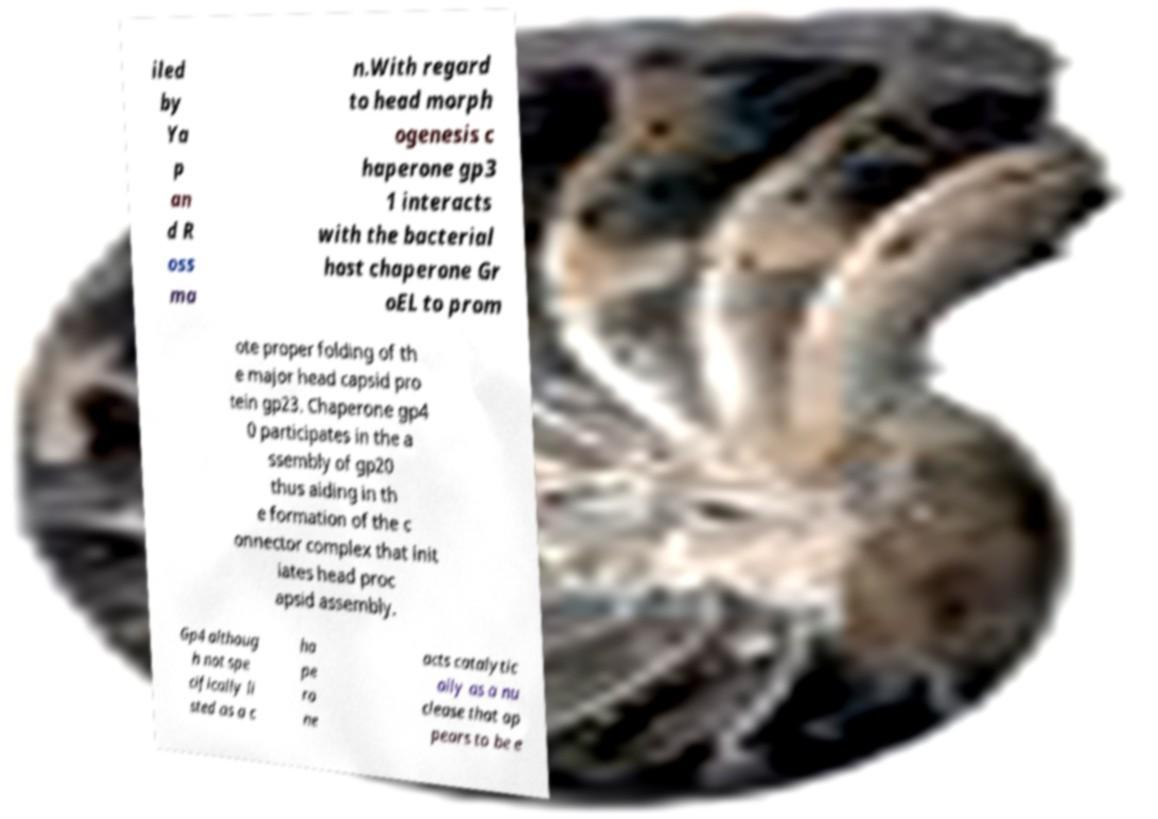There's text embedded in this image that I need extracted. Can you transcribe it verbatim? iled by Ya p an d R oss ma n.With regard to head morph ogenesis c haperone gp3 1 interacts with the bacterial host chaperone Gr oEL to prom ote proper folding of th e major head capsid pro tein gp23. Chaperone gp4 0 participates in the a ssembly of gp20 thus aiding in th e formation of the c onnector complex that init iates head proc apsid assembly. Gp4 althoug h not spe cifically li sted as a c ha pe ro ne acts catalytic ally as a nu clease that ap pears to be e 